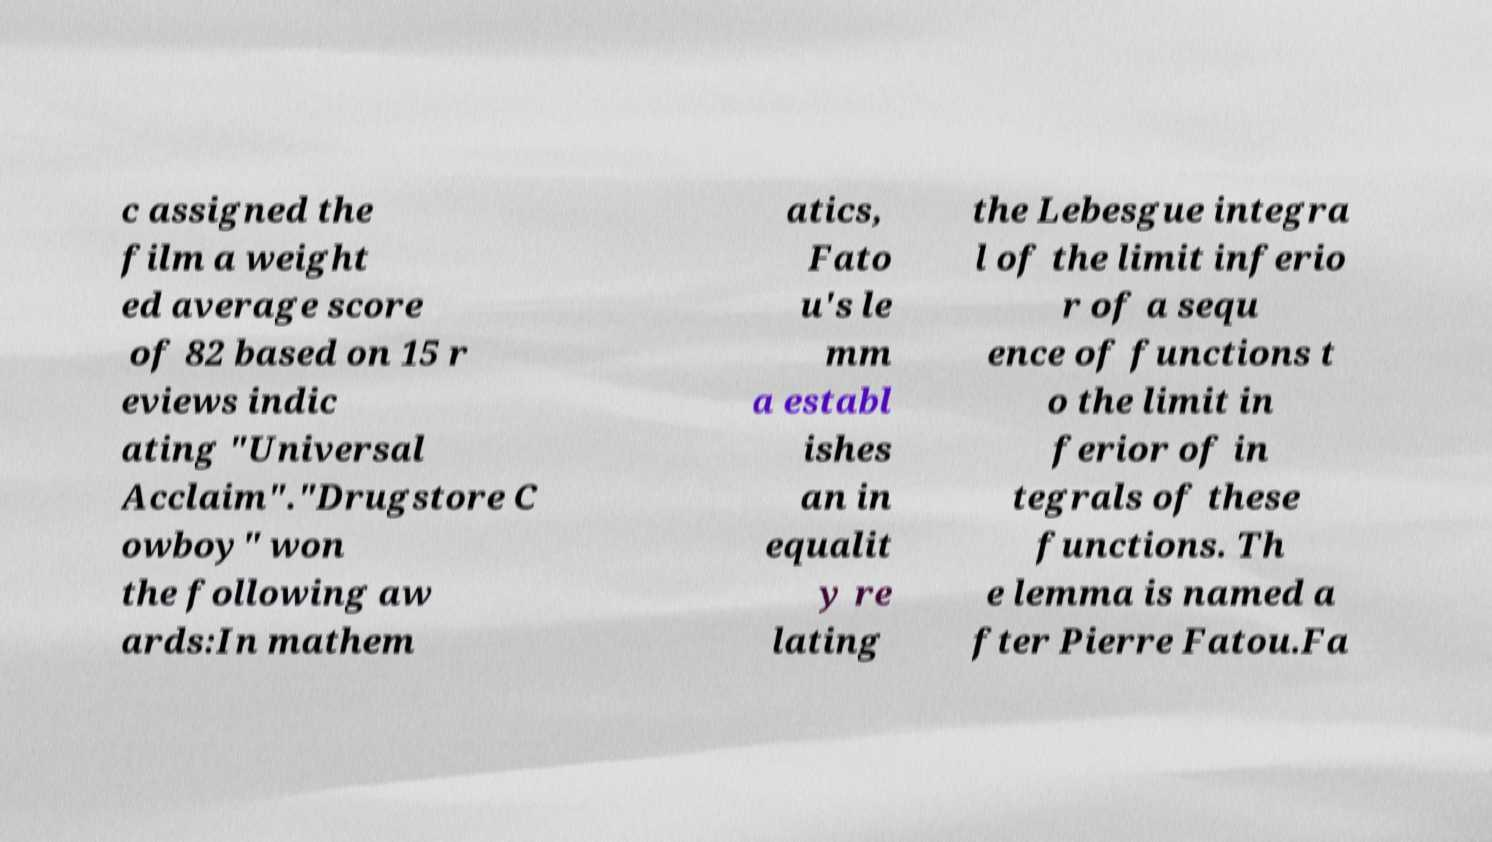Can you accurately transcribe the text from the provided image for me? c assigned the film a weight ed average score of 82 based on 15 r eviews indic ating "Universal Acclaim"."Drugstore C owboy" won the following aw ards:In mathem atics, Fato u's le mm a establ ishes an in equalit y re lating the Lebesgue integra l of the limit inferio r of a sequ ence of functions t o the limit in ferior of in tegrals of these functions. Th e lemma is named a fter Pierre Fatou.Fa 